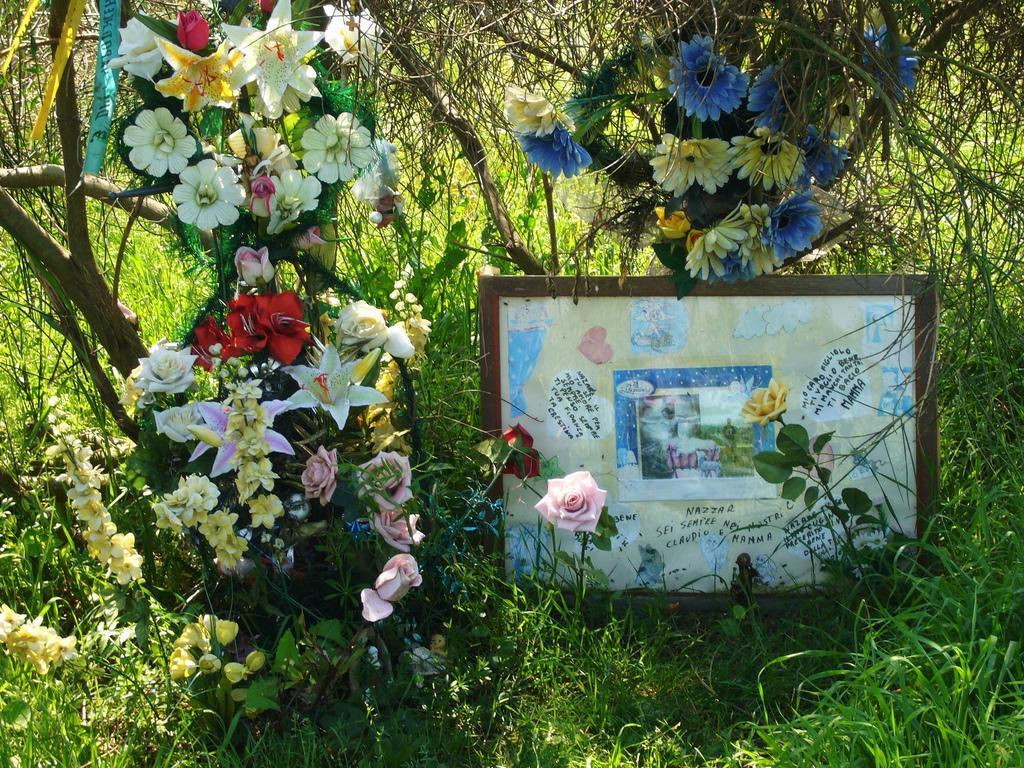What type of flora can be seen in the image? There are flowers, trees, and plants in the image. What else is present in the image besides flora? There are photo frames in the image. What is the process of existence for the week in the image? There is no reference to a week or any process of existence in the image; it features flowers, trees, plants, and photo frames. 